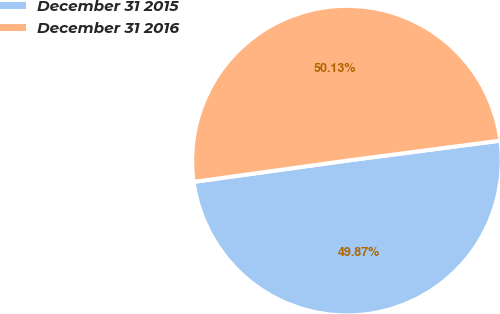Convert chart to OTSL. <chart><loc_0><loc_0><loc_500><loc_500><pie_chart><fcel>December 31 2015<fcel>December 31 2016<nl><fcel>49.87%<fcel>50.13%<nl></chart> 